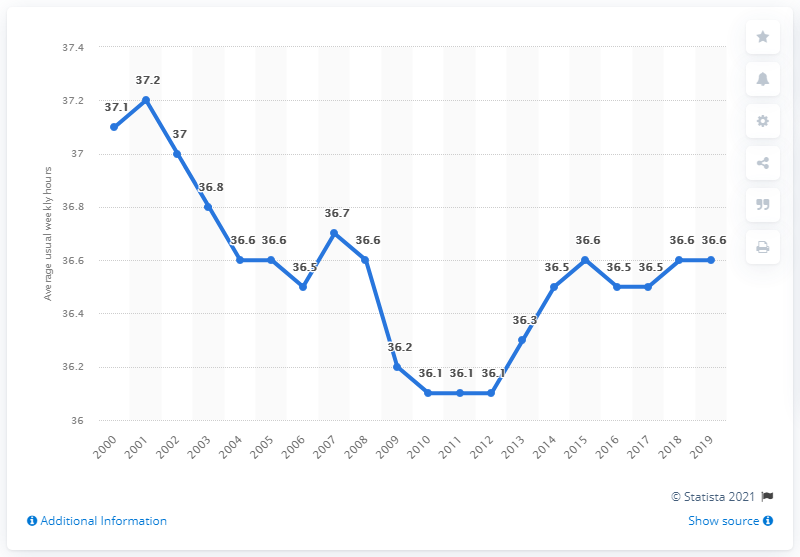Outline some significant characteristics in this image. In 2001, the average weekly working hours was 37.2 hours. 